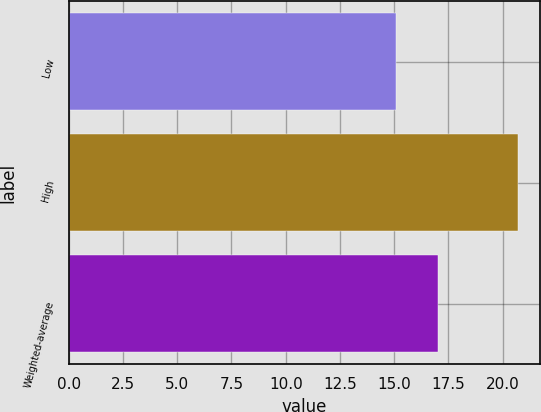<chart> <loc_0><loc_0><loc_500><loc_500><bar_chart><fcel>Low<fcel>High<fcel>Weighted-average<nl><fcel>15.1<fcel>20.7<fcel>17<nl></chart> 